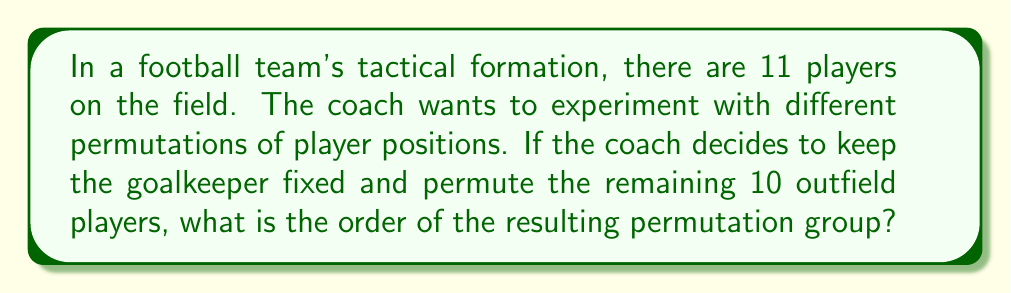Can you answer this question? Let's approach this step-by-step:

1) First, we need to understand what the question is asking. We're looking for the order of a permutation group, which is the number of elements in the group.

2) In this case, we have 10 players who can be arranged in any order. This is equivalent to finding the number of permutations of 10 objects.

3) The number of permutations of $n$ distinct objects is given by $n!$ (n factorial).

4) In our case, $n = 10$, so we need to calculate $10!$

5) Let's expand this:

   $$10! = 10 \times 9 \times 8 \times 7 \times 6 \times 5 \times 4 \times 3 \times 2 \times 1$$

6) Calculating this out:

   $$10! = 3,628,800$$

7) This means there are 3,628,800 different ways to arrange the 10 outfield players.

8) In group theory, each of these arrangements is an element of the permutation group, and the number of elements is the order of the group.

Therefore, the order of the permutation group representing the possible formations of the 10 outfield players is 3,628,800.
Answer: The order of the permutation group is 3,628,800. 